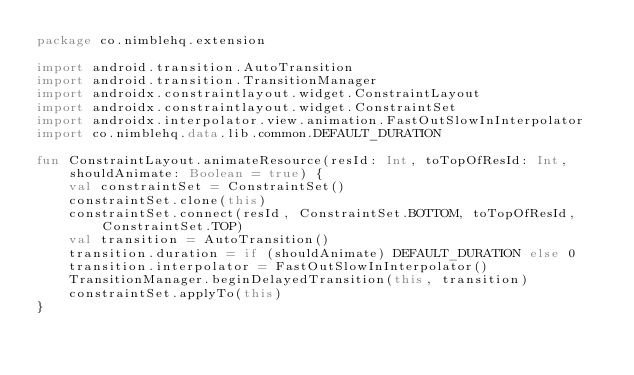Convert code to text. <code><loc_0><loc_0><loc_500><loc_500><_Kotlin_>package co.nimblehq.extension

import android.transition.AutoTransition
import android.transition.TransitionManager
import androidx.constraintlayout.widget.ConstraintLayout
import androidx.constraintlayout.widget.ConstraintSet
import androidx.interpolator.view.animation.FastOutSlowInInterpolator
import co.nimblehq.data.lib.common.DEFAULT_DURATION

fun ConstraintLayout.animateResource(resId: Int, toTopOfResId: Int, shouldAnimate: Boolean = true) {
    val constraintSet = ConstraintSet()
    constraintSet.clone(this)
    constraintSet.connect(resId, ConstraintSet.BOTTOM, toTopOfResId, ConstraintSet.TOP)
    val transition = AutoTransition()
    transition.duration = if (shouldAnimate) DEFAULT_DURATION else 0
    transition.interpolator = FastOutSlowInInterpolator()
    TransitionManager.beginDelayedTransition(this, transition)
    constraintSet.applyTo(this)
}
</code> 